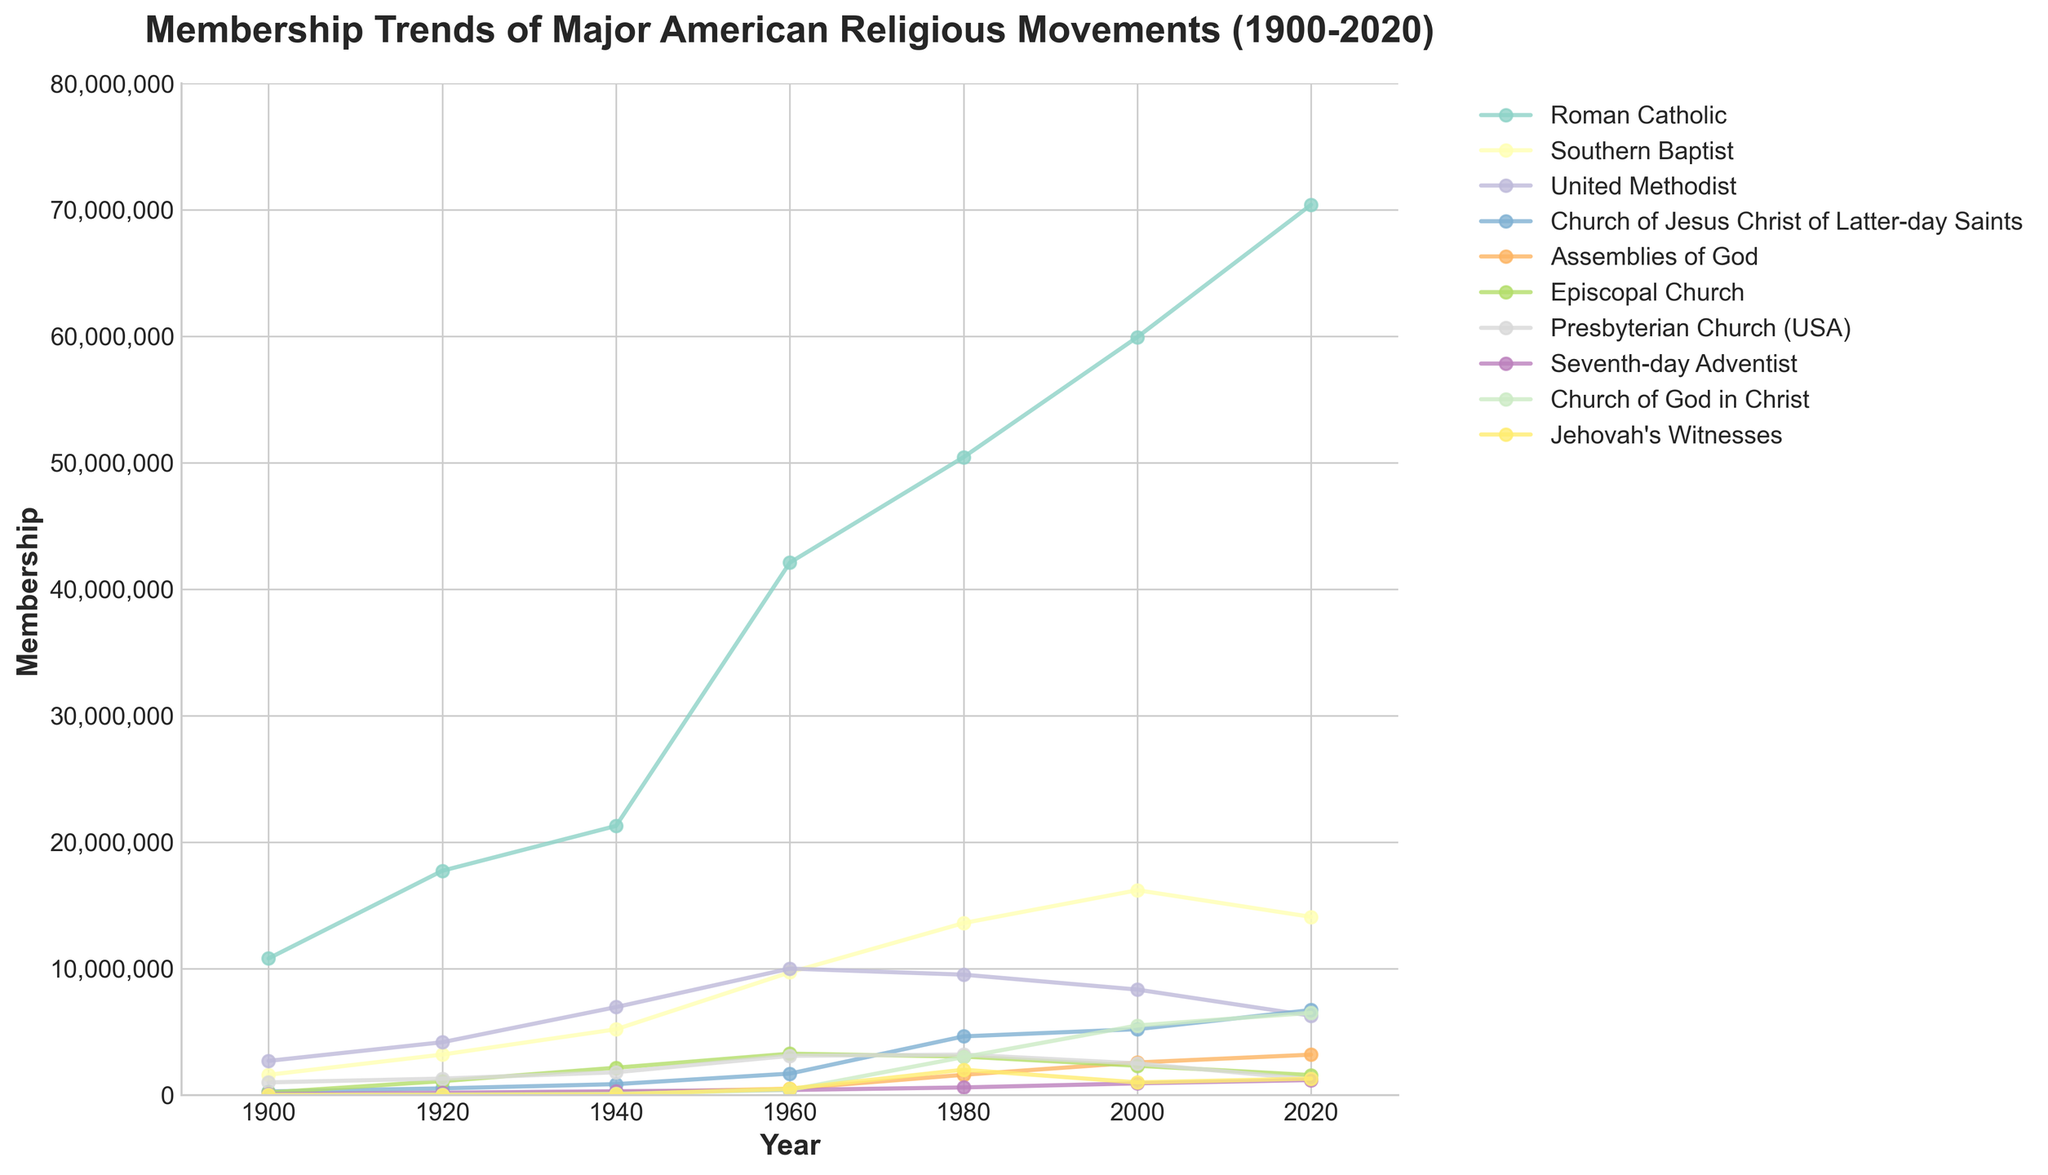What is the trend of Roman Catholic membership from 1900 to 2020? The trend for Roman Catholic membership shows a consistent increase from 10,800,000 in 1900 to 70,412,021 in 2020.
Answer: Increasing Which denomination had the highest membership in 2020? By looking at the heights of the lines in 2020 on the y-axis, the Roman Catholic denomination had the highest membership with 70,412,021 members.
Answer: Roman Catholic How did the membership for Southern Baptists change between 1960 and 2020? In 1960, the membership of Southern Baptists was 9,700,000, and in 2020, it was 14,089,947. The difference is 14,089,947 - 9,700,000.
Answer: Increased by 4,389,947 Which denominations show a decline in membership from 2000 to 2020? The denominations with a decline in membership are the Southern Baptist Convention, United Methodist Church, Episcopal Church, and Presbyterian Church (USA). This is observed by the downward trend in their lines between the years 2000 and 2020.
Answer: Southern Baptist, United Methodist, Episcopal Church, Presbyterian Church (USA) Compare the membership trends of the Church of Jesus Christ of Latter-day Saints and Assemblies of God from 1900 to 2020. The Church of Jesus Christ of Latter-day Saints' membership consistently rises from 283,000 in 1900 to 6,720,000 in 2020, while Assemblies of God also rises from 0 in 1900 to 3,192,112 in 2020. However, the growth for the Church of Jesus Christ of Latter-day Saints is steeper and higher overall.
Answer: Both increasing, but the Church of Jesus Christ of Latter-day Saints has a steeper and higher rise What is the sum of memberships for all denominations in 1980? Summing up the membership numbers for 1980 across all denominations: 50,450,000 + 13,600,000 + 9,519,407 + 4,639,000 + 1,600,000 + 3,041,198 + 3,200,000 + 600,000 + 3,000,000 + 2,000,000 = 91,649,605.
Answer: 91,649,605 Which denomination had the smallest increase in membership between 1920 and 1940? From the numbers, we can see that Jehovah's Witnesses had the smallest increase from 5,000 in 1920 to 50,000 in 1940, resulting in an increase of only 45,000.
Answer: Jehovah's Witnesses 